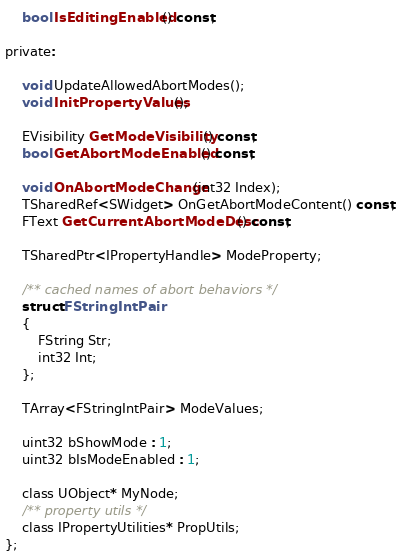<code> <loc_0><loc_0><loc_500><loc_500><_C_>	bool IsEditingEnabled() const;

private:

	void UpdateAllowedAbortModes();
	void InitPropertyValues();

	EVisibility GetModeVisibility() const;
	bool GetAbortModeEnabled() const;

	void OnAbortModeChange(int32 Index);
	TSharedRef<SWidget> OnGetAbortModeContent() const;
	FText GetCurrentAbortModeDesc() const;

	TSharedPtr<IPropertyHandle> ModeProperty;

	/** cached names of abort behaviors */
	struct FStringIntPair
	{
		FString Str;
		int32 Int;
	};

	TArray<FStringIntPair> ModeValues;

	uint32 bShowMode : 1;
	uint32 bIsModeEnabled : 1;

	class UObject* MyNode;
	/** property utils */
	class IPropertyUtilities* PropUtils;
};
</code> 